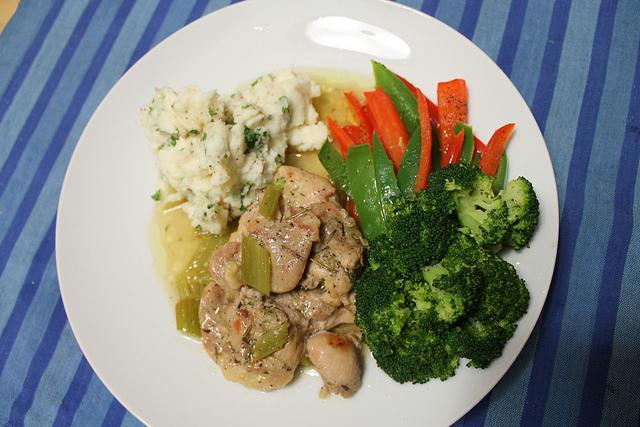What color is the plate?
Write a very short answer. White. What is the green item on the plate?
Concise answer only. Broccoli. Is there a tablecloth on the table?
Keep it brief. Yes. What style of potatoes are across from the broccoli?
Answer briefly. Mashed. Are there any sliced vegetables on the plate?
Quick response, please. Yes. 